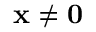<formula> <loc_0><loc_0><loc_500><loc_500>x \neq 0</formula> 